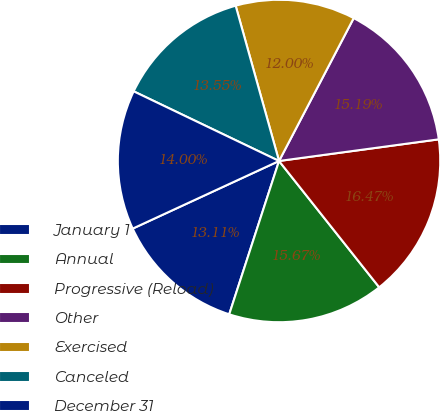Convert chart to OTSL. <chart><loc_0><loc_0><loc_500><loc_500><pie_chart><fcel>January 1<fcel>Annual<fcel>Progressive (Reload)<fcel>Other<fcel>Exercised<fcel>Canceled<fcel>December 31<nl><fcel>13.11%<fcel>15.67%<fcel>16.47%<fcel>15.19%<fcel>12.0%<fcel>13.55%<fcel>14.0%<nl></chart> 